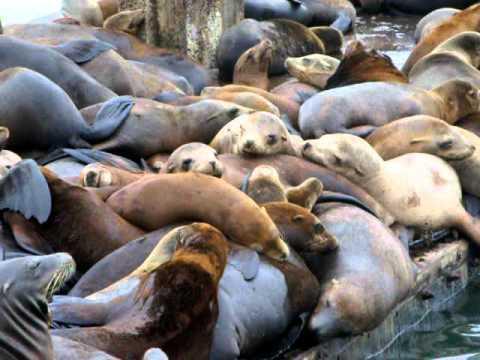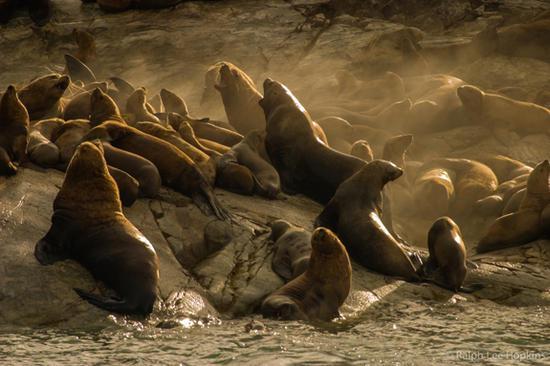The first image is the image on the left, the second image is the image on the right. Analyze the images presented: Is the assertion "Exactly four seal heads are visible in one of the images." valid? Answer yes or no. No. The first image is the image on the left, the second image is the image on the right. Given the left and right images, does the statement "The right image contains no more than four seals." hold true? Answer yes or no. No. 